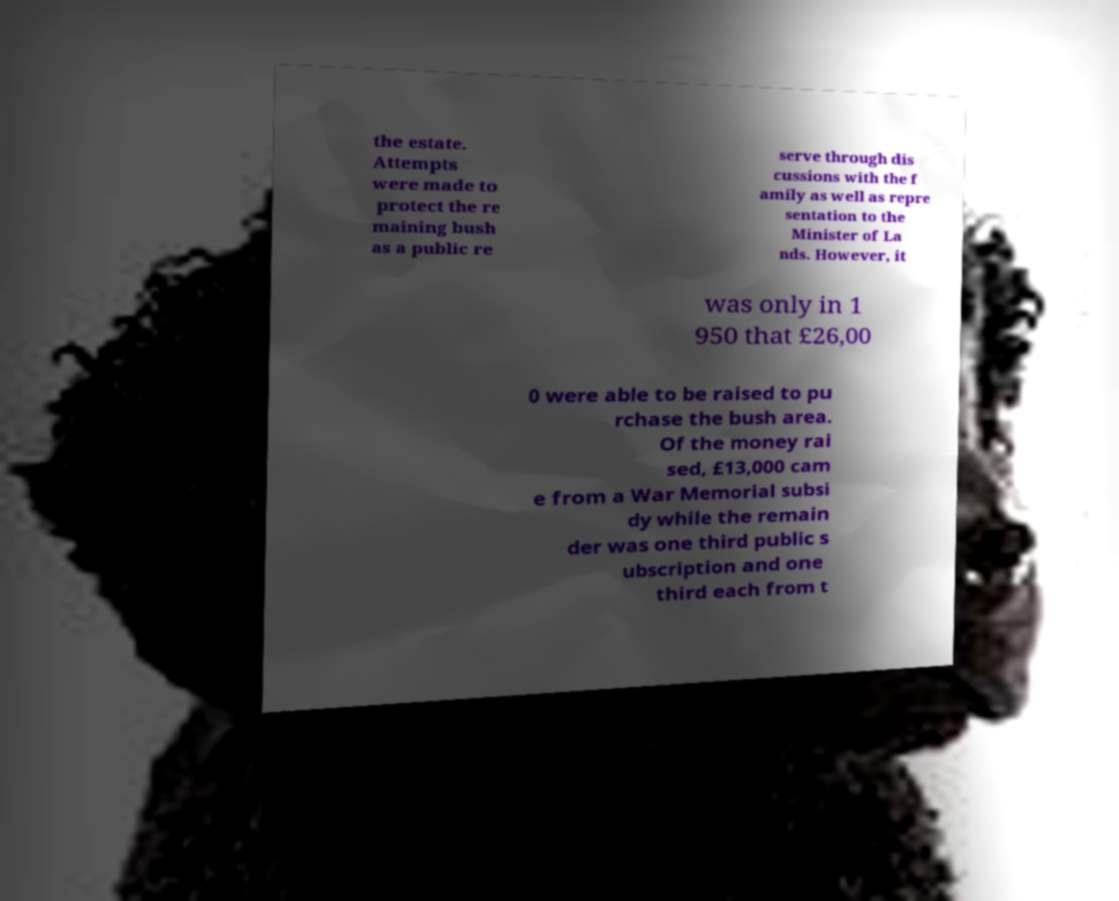I need the written content from this picture converted into text. Can you do that? the estate. Attempts were made to protect the re maining bush as a public re serve through dis cussions with the f amily as well as repre sentation to the Minister of La nds. However, it was only in 1 950 that £26,00 0 were able to be raised to pu rchase the bush area. Of the money rai sed, £13,000 cam e from a War Memorial subsi dy while the remain der was one third public s ubscription and one third each from t 